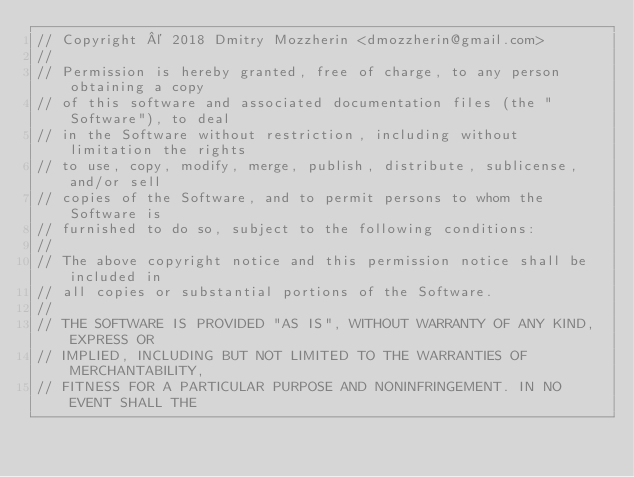Convert code to text. <code><loc_0><loc_0><loc_500><loc_500><_Go_>// Copyright © 2018 Dmitry Mozzherin <dmozzherin@gmail.com>
//
// Permission is hereby granted, free of charge, to any person obtaining a copy
// of this software and associated documentation files (the "Software"), to deal
// in the Software without restriction, including without limitation the rights
// to use, copy, modify, merge, publish, distribute, sublicense, and/or sell
// copies of the Software, and to permit persons to whom the Software is
// furnished to do so, subject to the following conditions:
//
// The above copyright notice and this permission notice shall be included in
// all copies or substantial portions of the Software.
//
// THE SOFTWARE IS PROVIDED "AS IS", WITHOUT WARRANTY OF ANY KIND, EXPRESS OR
// IMPLIED, INCLUDING BUT NOT LIMITED TO THE WARRANTIES OF MERCHANTABILITY,
// FITNESS FOR A PARTICULAR PURPOSE AND NONINFRINGEMENT. IN NO EVENT SHALL THE</code> 